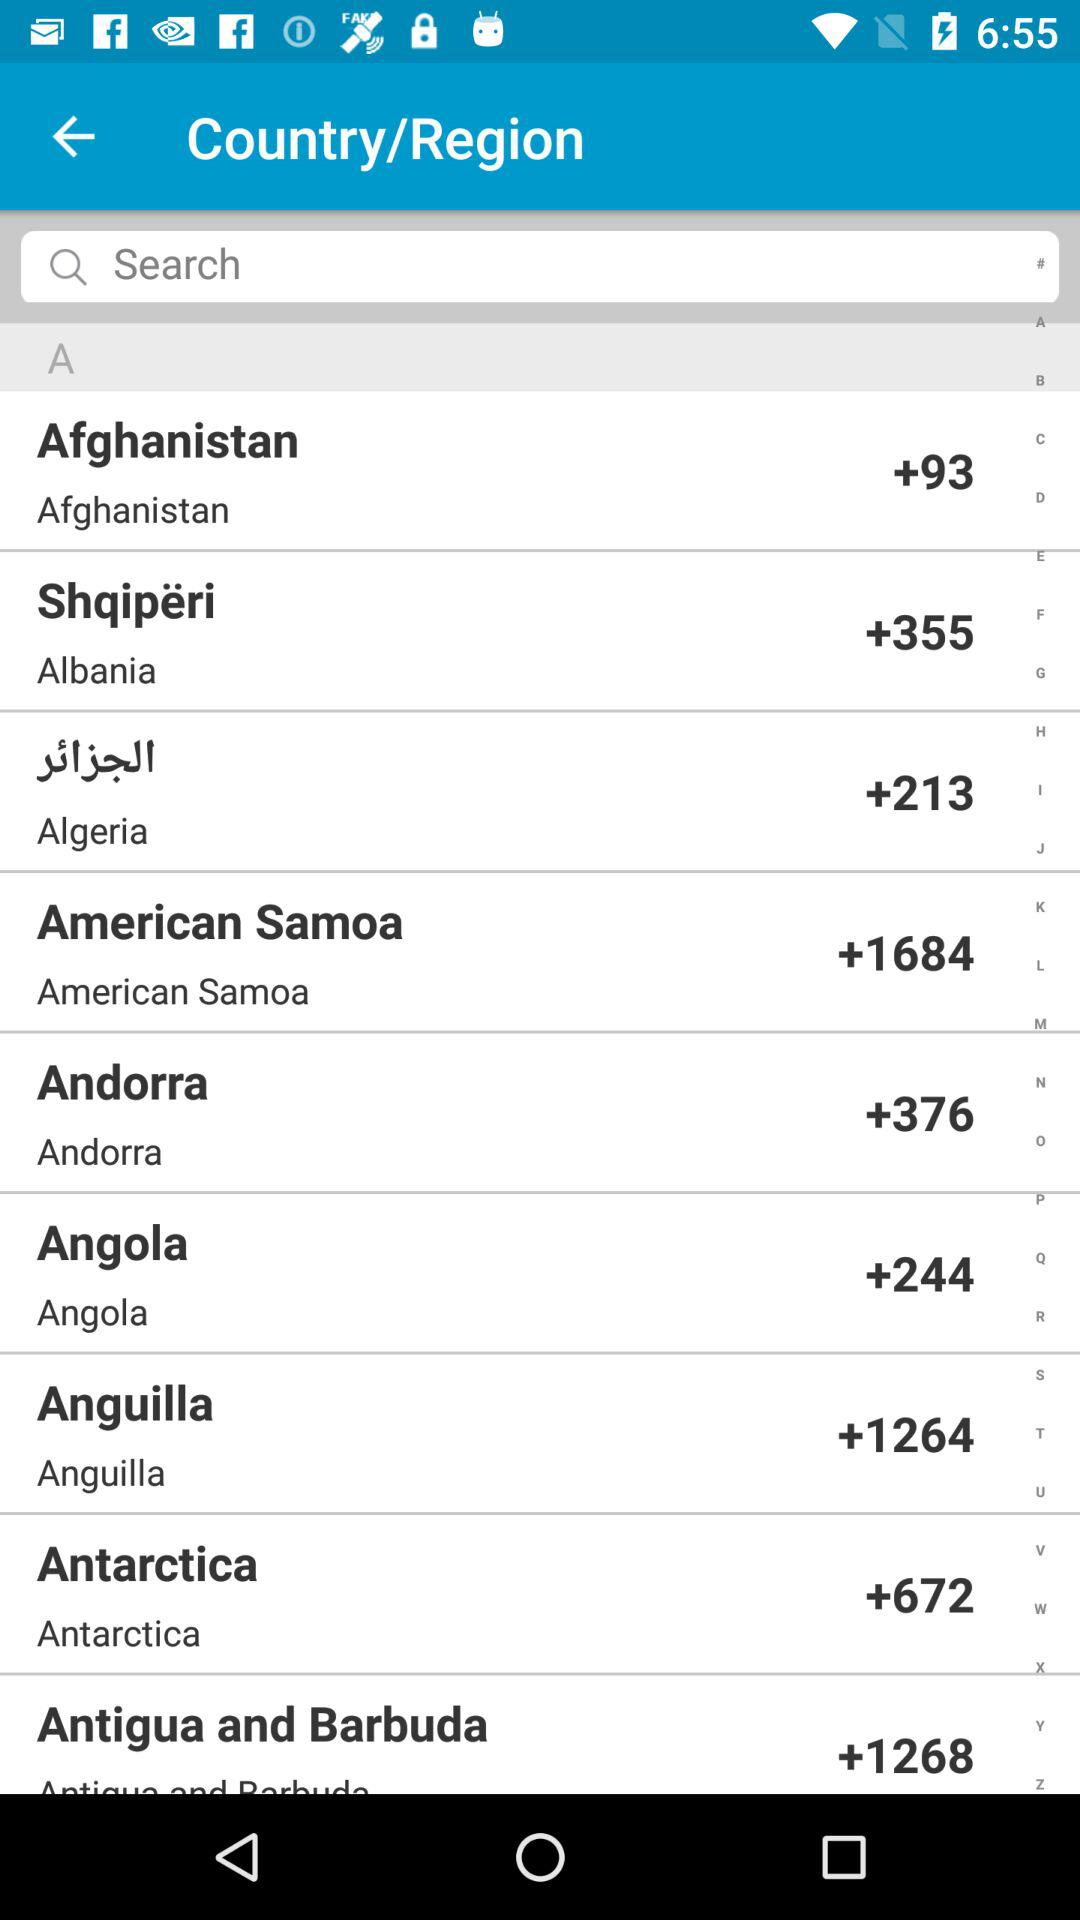Which country has the +1264 code? The country that has the +1264 code is Anguilla. 